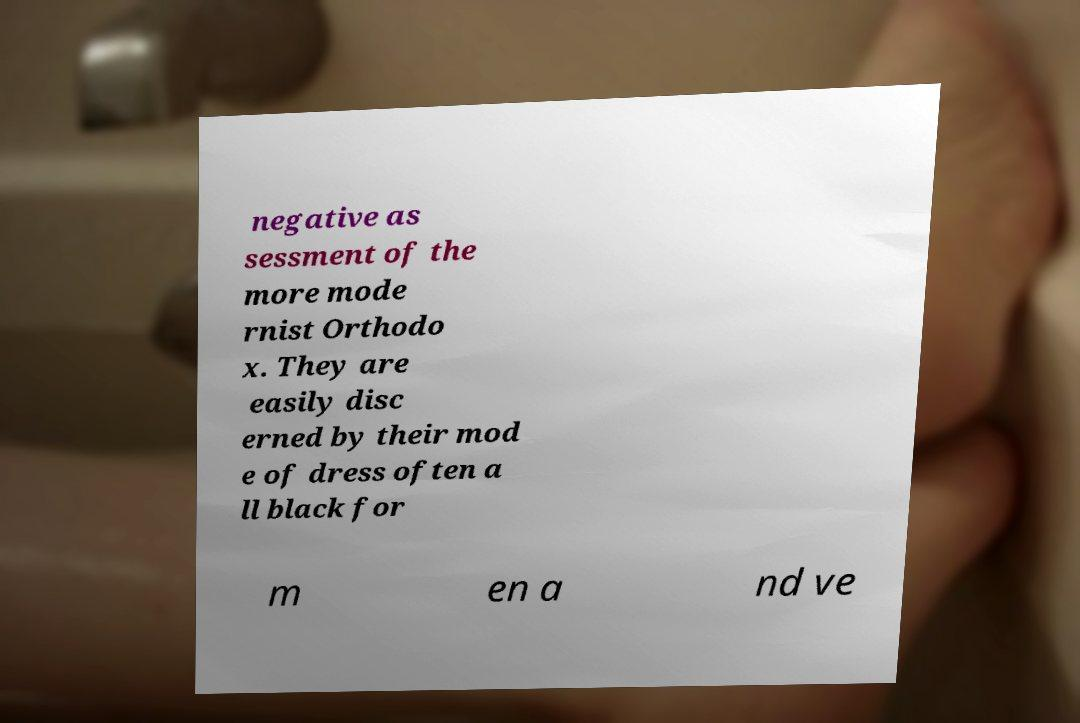Could you assist in decoding the text presented in this image and type it out clearly? negative as sessment of the more mode rnist Orthodo x. They are easily disc erned by their mod e of dress often a ll black for m en a nd ve 